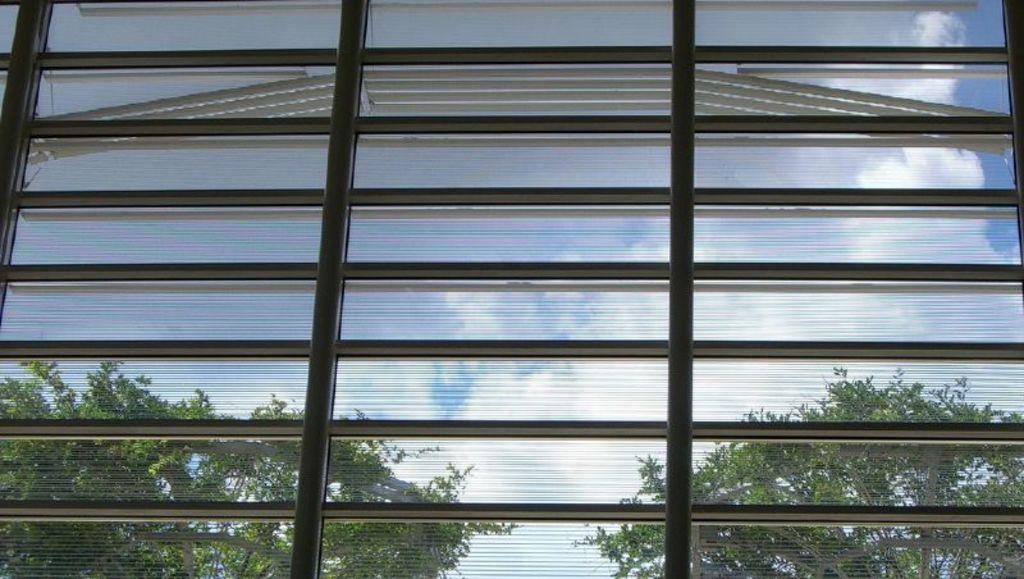Please provide a concise description of this image. In this picture, we see a glass window from which we can see trees, clouds and the sky. 